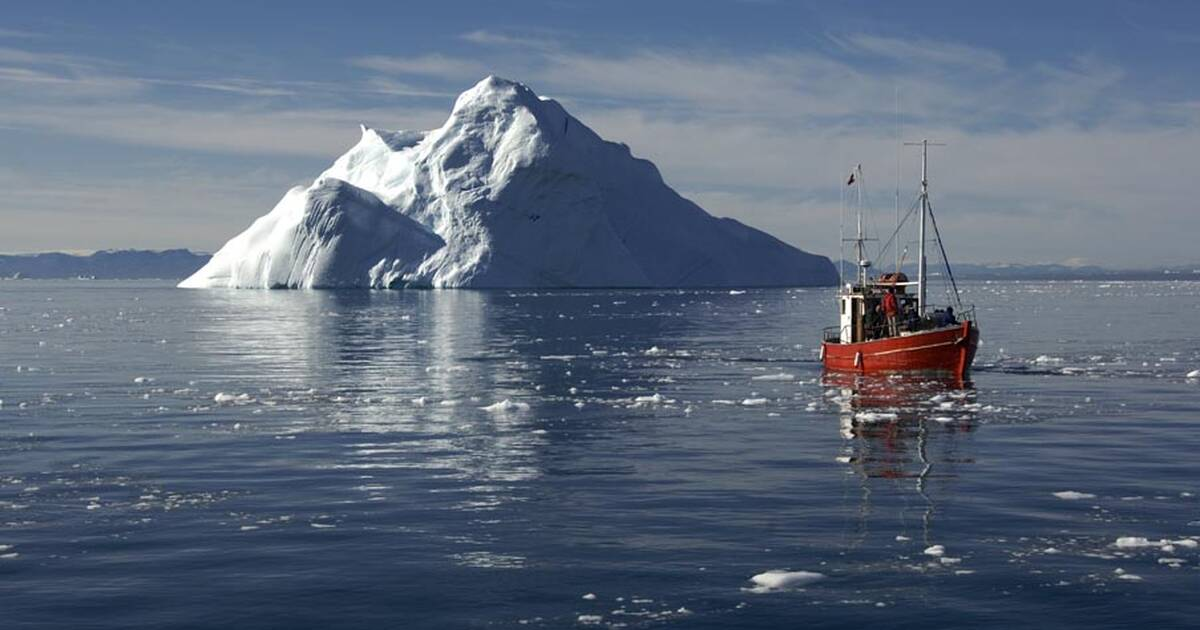What are the potential challenges faced by fishing boats in such a location? The fishing boats operating in the Ilulissat Icefjord face several formidable challenges. The most obvious is the presence of icebergs and smaller ice floes, which can pose significant navigational hazards. Boats must be equipped to handle collisions or the sudden shifts of ice that can occur without warning. The cold temperatures can cause equipment to freeze or malfunction, necessitating specialized gear and maintenance. Moreover, the remoteness of the location means that help is not immediately available, so crews must be self-sufficient and well-prepared for emergencies. Weather conditions can also change rapidly, with sudden storms making the waters treacherous. Lastly, the environmental impact of fishing in such a pristine area requires careful management to ensure that the natural beauty and ecological balance of the Icefjord are preserved. 